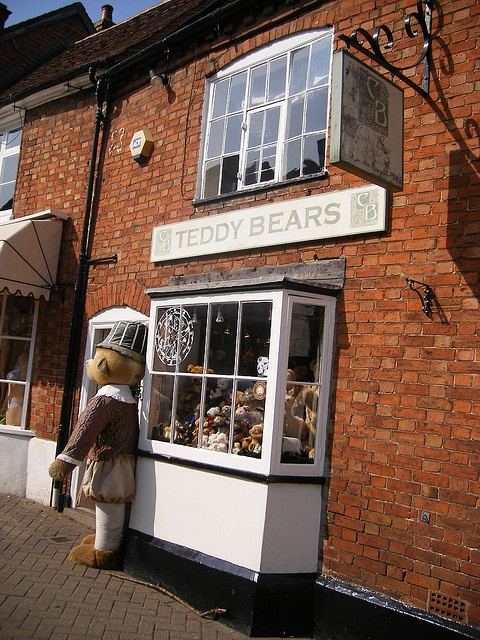Describe the objects in this image and their specific colors. I can see teddy bear in gray, black, and maroon tones, teddy bear in gray, maroon, black, and brown tones, teddy bear in gray, black, brown, and maroon tones, teddy bear in gray, black, and maroon tones, and teddy bear in gray, black, maroon, and brown tones in this image. 